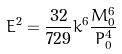<formula> <loc_0><loc_0><loc_500><loc_500>E ^ { 2 } = { \frac { 3 2 } { 7 2 9 } } k ^ { 6 } { \frac { { M _ { 0 } ^ { 6 } } } { { P _ { 0 } ^ { 4 } } } }</formula> 